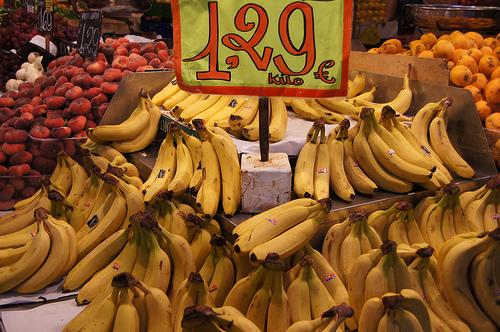Can you describe the color and content of the sign that displays the price of bananas? The sign is orange and yellow, and it says 129 per kilo. What are two color features in the image relating to the signs? The banana price sign is orange and yellow, while the other signs are black and white. Mention one fruit present in the image that may not be commonly known. Exotic fruit that looks like squashed peaches is present. Mention the most prominent fruit in the image and its display arrangement. Many bananas are displayed on the table in three rows: top, middle, and bottom. Describe the location where this picture is taken and the primary subjects in it. The picture is taken outside featuring a variety of fruits, prominently displaying bananas. Which fruit in the image has identifiable stickers on them? Bananas have stickers on them, with some showing the brand "Dole." Identify two different fruits in the image and their relative position to the banana display. Reddish orange fruit is on the left and orange colored fruit is on the right of the banana display. What type of image is this and what does it have a variety of? This is an outdoor picture with a variety of fruit shown. In few words, describe the overall content of the image. The image displays various fruits, including bananas, reddish orange fruit, and orange colored fruit. Talk about some details on the bananas in the image. The bananas are yellow and have stickers, including a Dole sticker on one of them. 